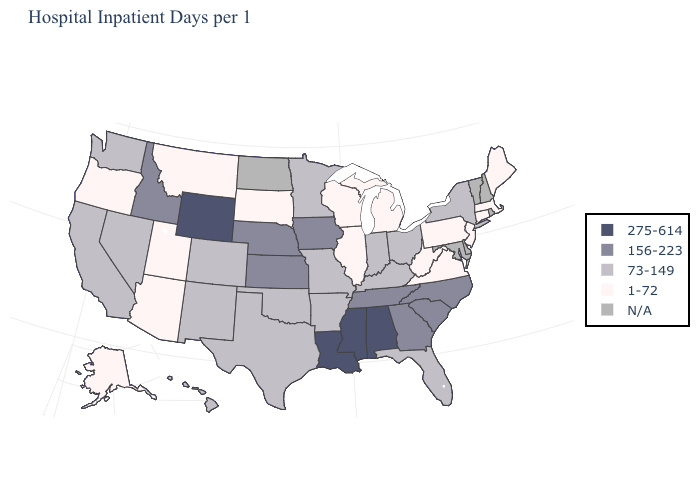Among the states that border Illinois , does Kentucky have the highest value?
Be succinct. No. What is the value of Arkansas?
Write a very short answer. 73-149. What is the value of Georgia?
Write a very short answer. 156-223. What is the lowest value in states that border Washington?
Short answer required. 1-72. Which states have the lowest value in the USA?
Keep it brief. Alaska, Arizona, Connecticut, Illinois, Maine, Massachusetts, Michigan, Montana, New Jersey, Oregon, Pennsylvania, South Dakota, Utah, Virginia, West Virginia, Wisconsin. What is the highest value in the USA?
Keep it brief. 275-614. What is the value of Louisiana?
Concise answer only. 275-614. What is the lowest value in the Northeast?
Write a very short answer. 1-72. Which states have the lowest value in the South?
Write a very short answer. Virginia, West Virginia. What is the value of Minnesota?
Be succinct. 73-149. Among the states that border North Carolina , which have the highest value?
Quick response, please. Georgia, South Carolina, Tennessee. What is the lowest value in the South?
Concise answer only. 1-72. What is the value of Illinois?
Keep it brief. 1-72. Name the states that have a value in the range N/A?
Concise answer only. Delaware, Maryland, New Hampshire, North Dakota, Rhode Island, Vermont. Which states have the lowest value in the USA?
Be succinct. Alaska, Arizona, Connecticut, Illinois, Maine, Massachusetts, Michigan, Montana, New Jersey, Oregon, Pennsylvania, South Dakota, Utah, Virginia, West Virginia, Wisconsin. 